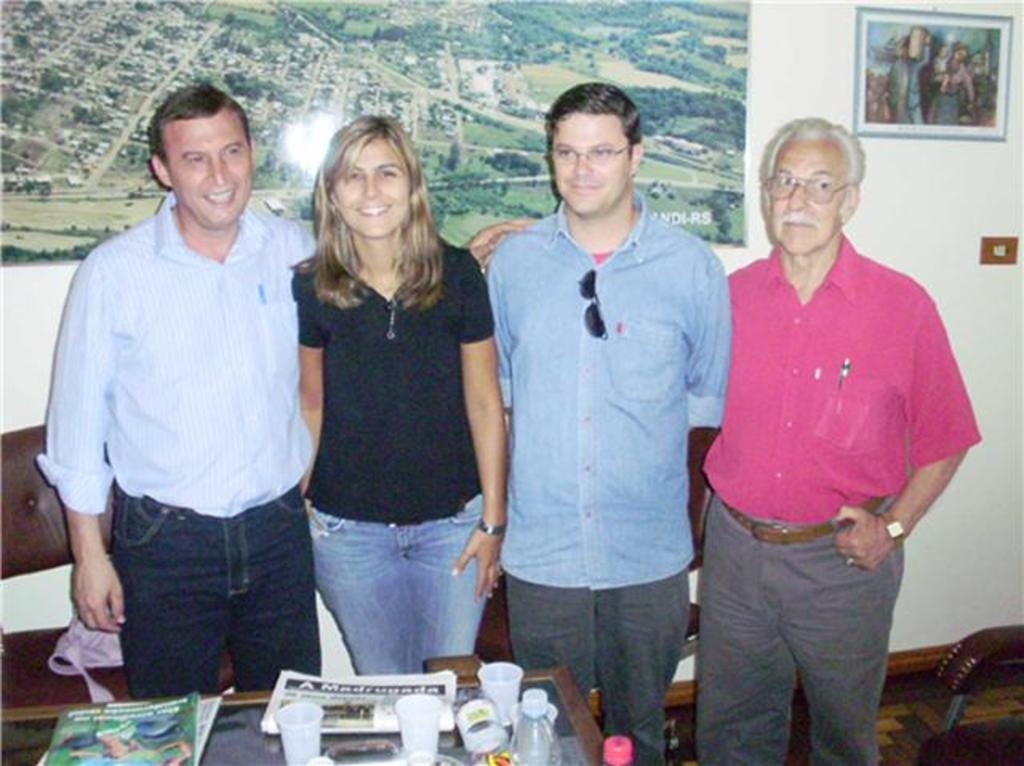What types of people are present in the image? There are men and women standing in the image. What objects can be seen on the table? There is a paper, a book, a glass, and a bottle on the table. Are there any items on the wall in the image? Yes, there are photo frames on the wall. What type of mitten is being used to hold the dinosaurs in the image? There are no mittens or dinosaurs present in the image. Is it raining in the image? There is no indication of rain in the image. 